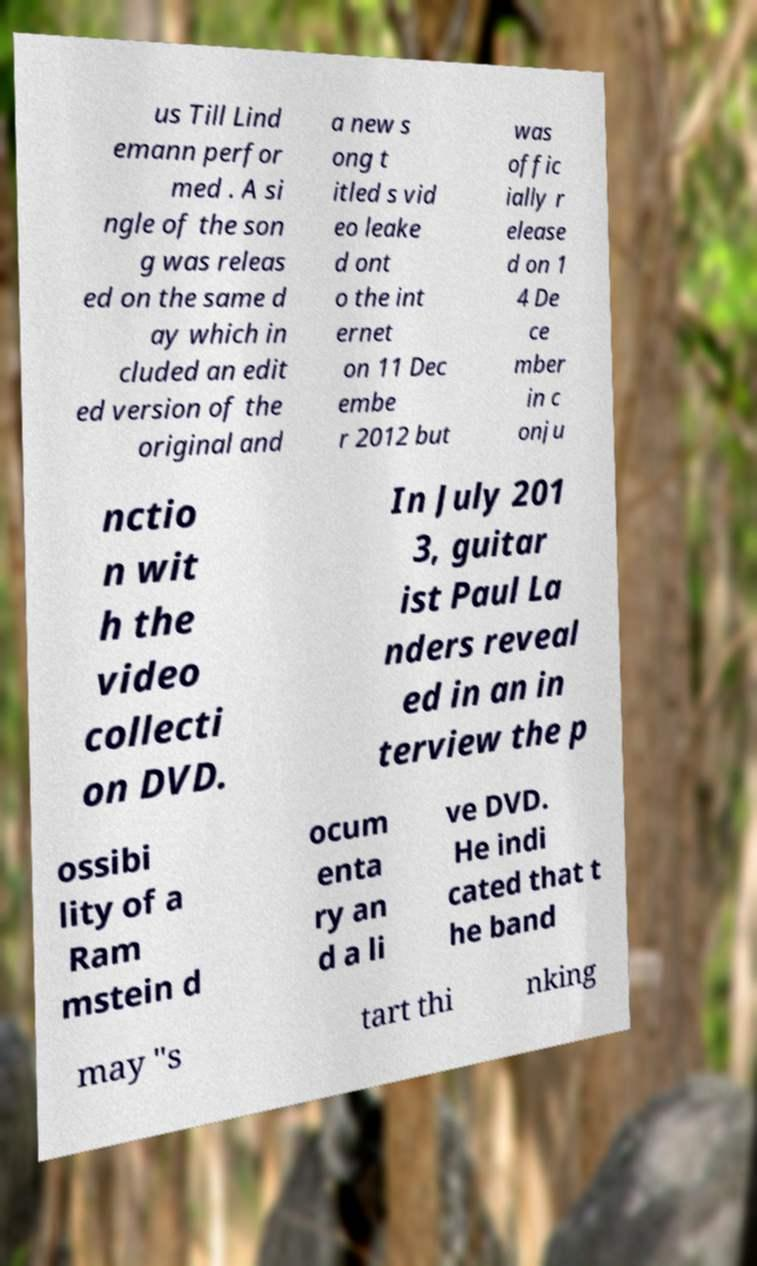Can you accurately transcribe the text from the provided image for me? us Till Lind emann perfor med . A si ngle of the son g was releas ed on the same d ay which in cluded an edit ed version of the original and a new s ong t itled s vid eo leake d ont o the int ernet on 11 Dec embe r 2012 but was offic ially r elease d on 1 4 De ce mber in c onju nctio n wit h the video collecti on DVD. In July 201 3, guitar ist Paul La nders reveal ed in an in terview the p ossibi lity of a Ram mstein d ocum enta ry an d a li ve DVD. He indi cated that t he band may "s tart thi nking 